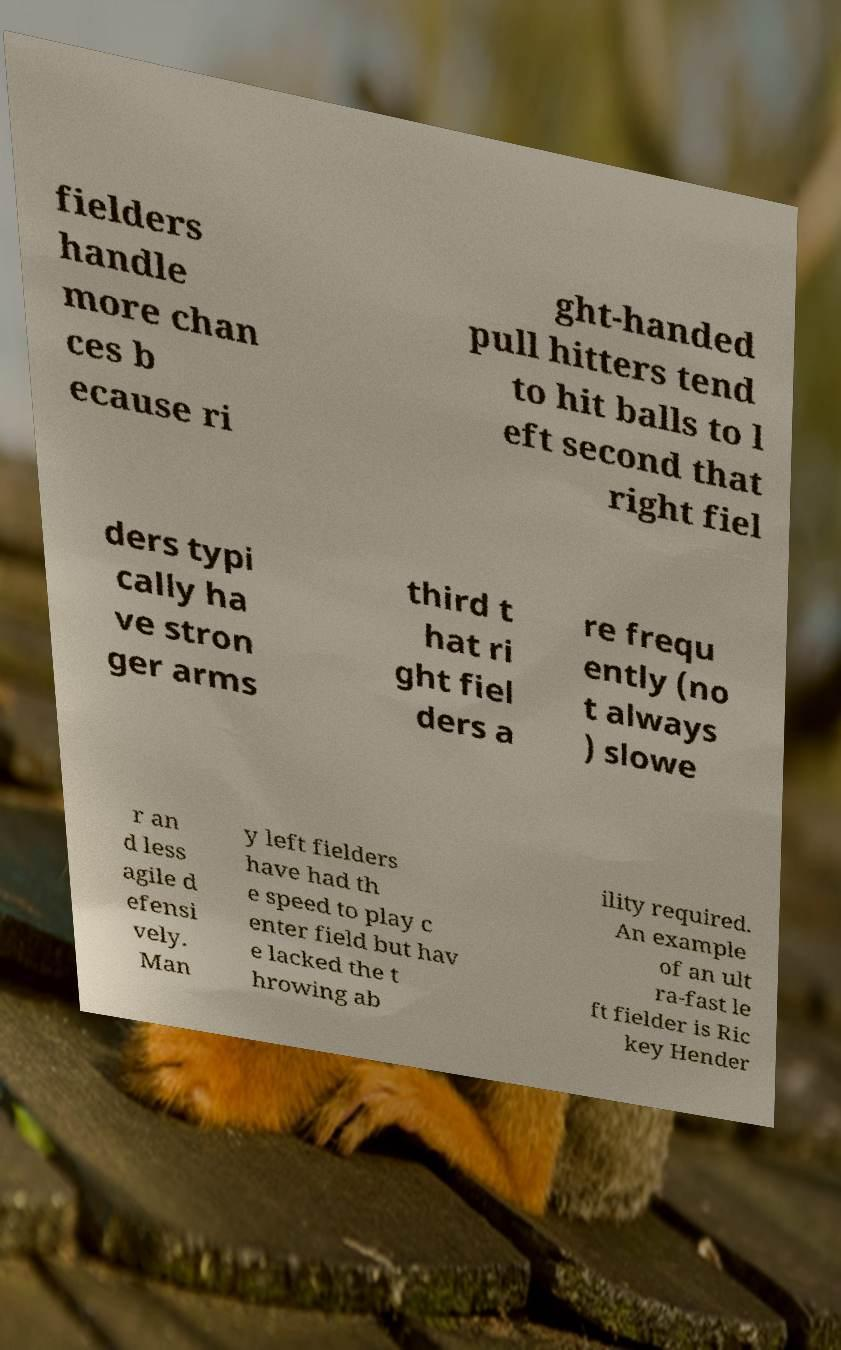For documentation purposes, I need the text within this image transcribed. Could you provide that? fielders handle more chan ces b ecause ri ght-handed pull hitters tend to hit balls to l eft second that right fiel ders typi cally ha ve stron ger arms third t hat ri ght fiel ders a re frequ ently (no t always ) slowe r an d less agile d efensi vely. Man y left fielders have had th e speed to play c enter field but hav e lacked the t hrowing ab ility required. An example of an ult ra-fast le ft fielder is Ric key Hender 